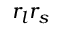Convert formula to latex. <formula><loc_0><loc_0><loc_500><loc_500>r _ { l } r _ { s }</formula> 